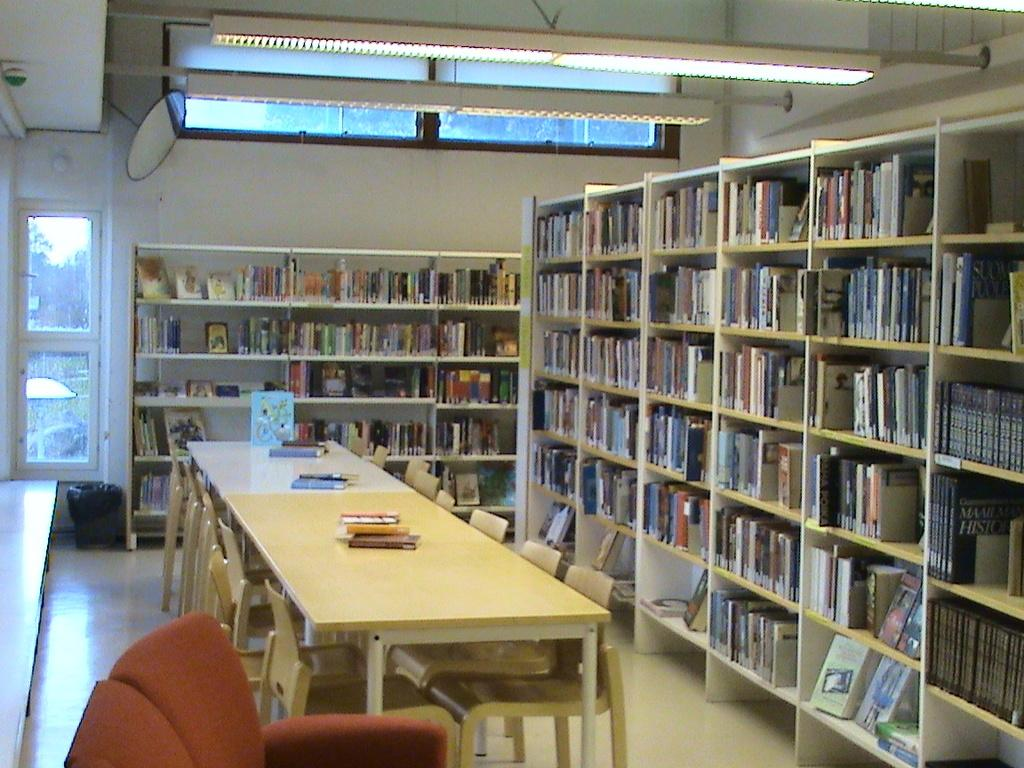Provide a one-sentence caption for the provided image. A libraby showing many books, including a set of History Encyclopedias. 